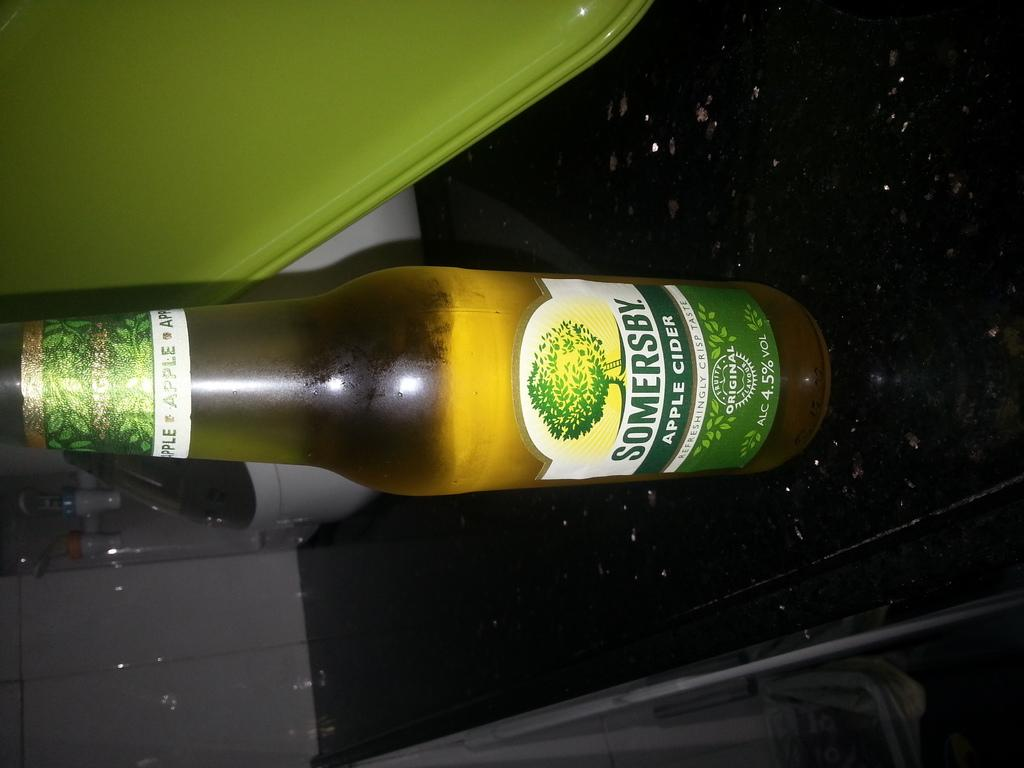<image>
Offer a succinct explanation of the picture presented. A bottle of Somersby sits on a black countertop. 